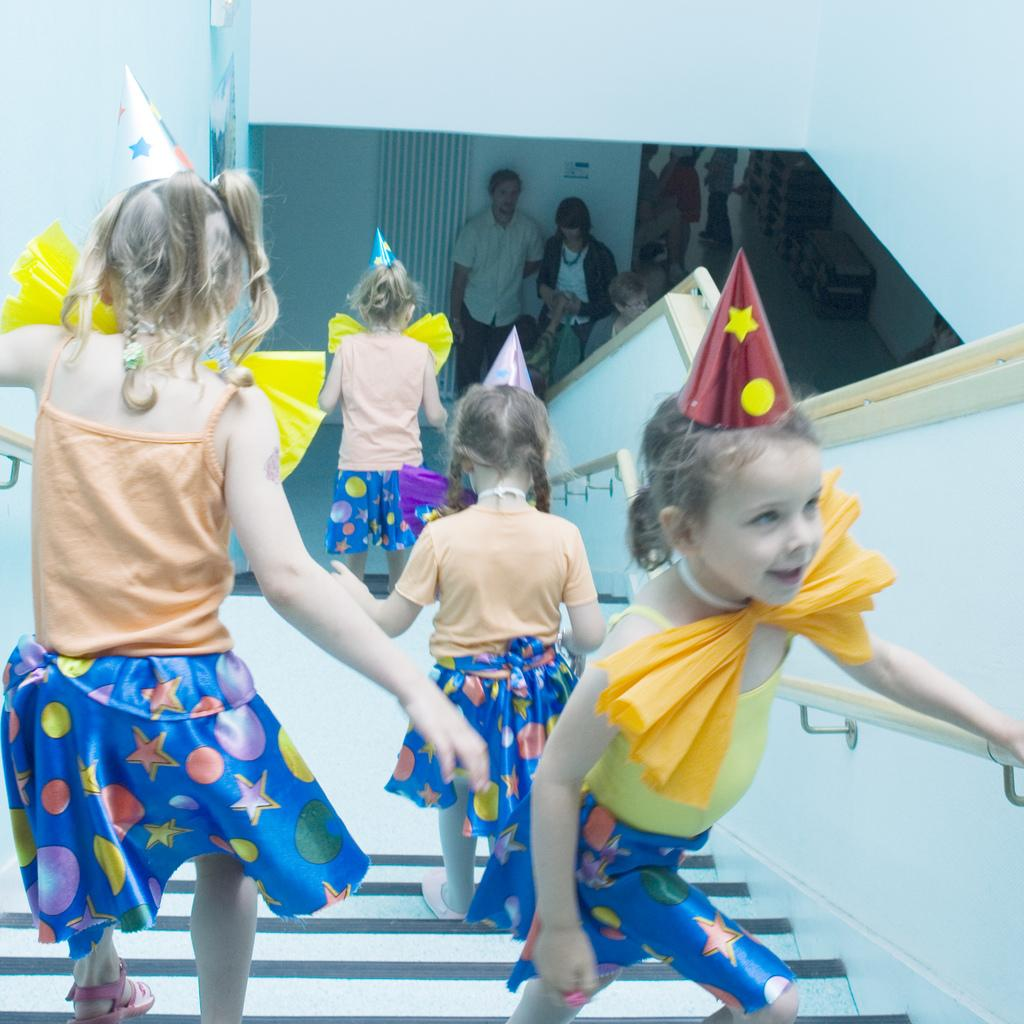What is happening in the image involving the children? The children are walking on the steps in the image. How are the children ensuring their safety while walking on the steps? The children are holding the railing while walking on the steps. Can you describe the people near the wall at the bottom of the steps? There are two people standing near the wall at the bottom of the steps. What is the birth rate of the spiders in the image? There are no spiders present in the image, so it is not possible to determine the birth rate. 